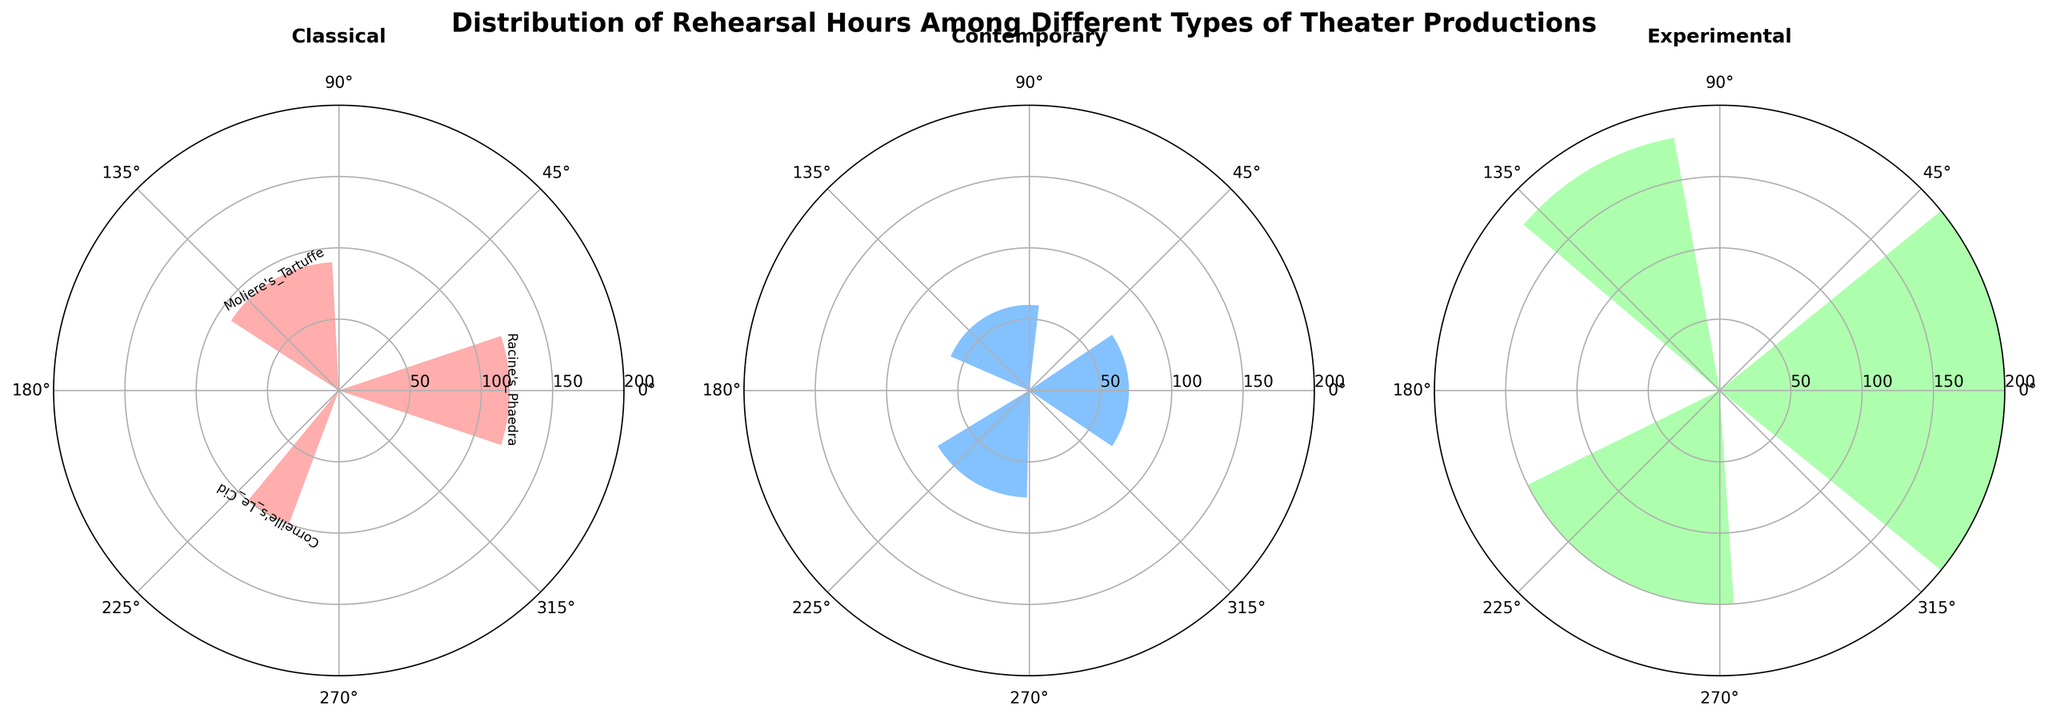What is the title of the figure? The title is located at the top of the figure and in bold. It reads "Distribution of Rehearsal Hours Among Different Types of Theater Productions."
Answer: Distribution of Rehearsal Hours Among Different Types of Theater Productions How many types of theater productions are displayed in the figure? The figure has three subplots, each with a title indicating the type of theater production: Classical, Contemporary, and Experimental.
Answer: 3 Which type of theater production has the highest rehearsal hours? By looking at the radii of the bars in each subplot, the Experimental category has the longest bar, representing Robert Wilson's "Einstein on the Beach" with 200 hours of rehearsal.
Answer: Experimental How many productions are categorized under Experimental? The subplot titled "Experimental" has three bars representing three productions: "Einstein on the Beach," "The Mahabharata," and "Hamletmachine."
Answer: 3 Do Classical productions generally have higher rehearsal hours compared to Contemporary productions? Compared to the radii of bars in the Classical and Contemporary subplots, Classical productions have rehearsal hours ranging from 90 to 120, while Contemporary productions range from 60 to 75. This shows Classical productions have generally higher rehearsal hours.
Answer: Yes What is the average rehearsal time for Contemporary productions? There are three Contemporary productions with rehearsal hours 70, 60, and 75. The sum is 205, and the average is 205/3 = 68.33 hours.
Answer: 68.33 hours Which Classical production had the lowest rehearsal hours? In the Classical subplot, the bar with the smallest radius represents Molière's "Tartuffe" with 90 hours.
Answer: Molière's "Tartuffe" By how many hours does "Einstein on the Beach" exceed the longest rehearsal hours in Contemporary productions? "Einstein on the Beach" has 200 hours, while the longest Contemporary production is "Marjorie Prime" with 75 hours. 200 - 75 = 125.
Answer: 125 hours What is the total amount of rehearsal hours for all Experimental productions? The Experimental subplot has three productions with 200, 180, and 150 hours. The total is 200 + 180 + 150 = 530 hours.
Answer: 530 hours What are the labels used along the radial line (y-axis) of the plots? The radial lines in all subplots have tick marks at intervals of 50, starting at 50 hours going up to the maximum rehearsal hours shown, which is 200.
Answer: 50, 100, 150, 200 